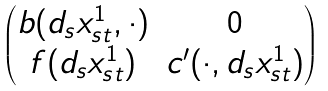<formula> <loc_0><loc_0><loc_500><loc_500>\begin{pmatrix} b ( d _ { s } x _ { s t } ^ { 1 } , \cdot ) & 0 \\ f ( d _ { s } x _ { s t } ^ { 1 } ) & c ^ { \prime } ( \cdot , d _ { s } x _ { s t } ^ { 1 } ) \end{pmatrix}</formula> 